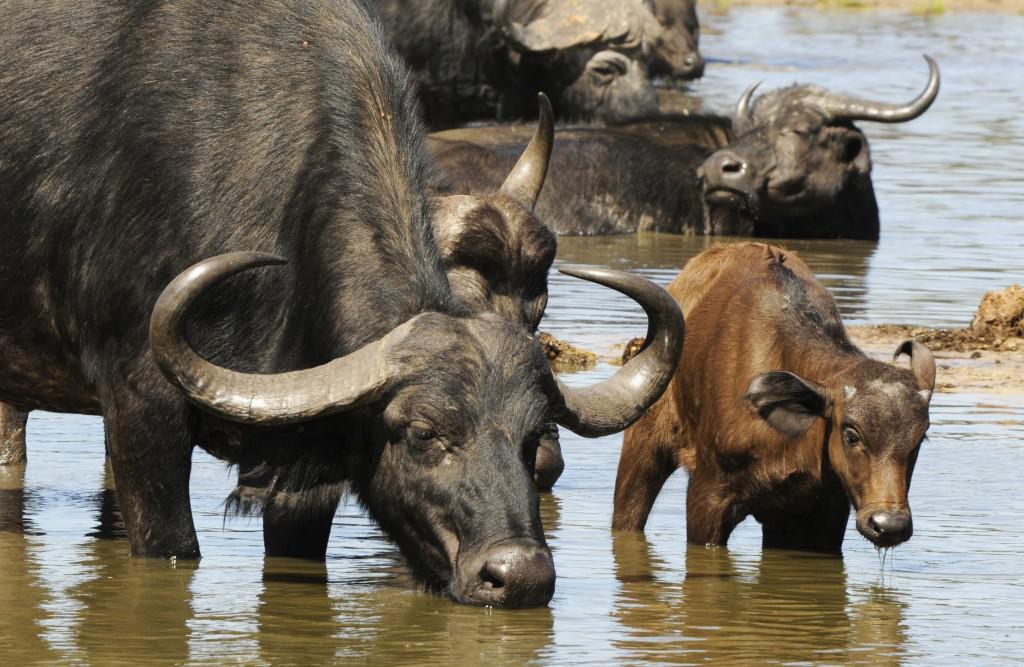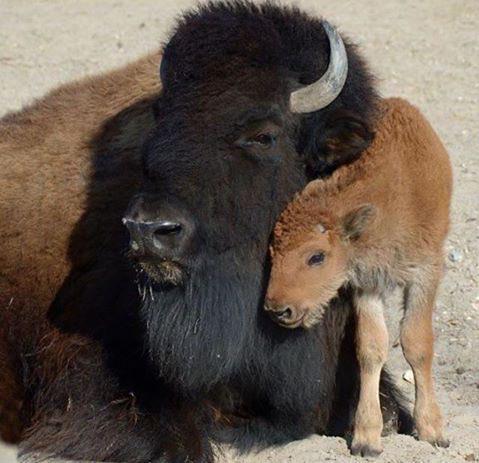The first image is the image on the left, the second image is the image on the right. Given the left and right images, does the statement "The left image includes a forward-facing buffalo with other buffalo in the background at the left, and the right image shows a buffalo with a different type of animal on its back." hold true? Answer yes or no. No. The first image is the image on the left, the second image is the image on the right. For the images displayed, is the sentence "In at least one image there is a single round horned ox standing next to it brown cafe" factually correct? Answer yes or no. Yes. 